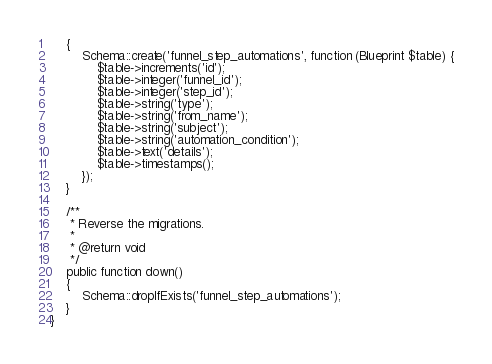Convert code to text. <code><loc_0><loc_0><loc_500><loc_500><_PHP_>    {
        Schema::create('funnel_step_automations', function (Blueprint $table) {
            $table->increments('id');
            $table->integer('funnel_id');
            $table->integer('step_id');
            $table->string('type');
            $table->string('from_name');
            $table->string('subject');
            $table->string('automation_condition');
            $table->text('details');
            $table->timestamps();
        });
    }

    /**
     * Reverse the migrations.
     *
     * @return void
     */
    public function down()
    {
        Schema::dropIfExists('funnel_step_automations');
    }
}
</code> 